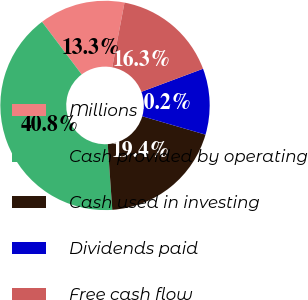<chart> <loc_0><loc_0><loc_500><loc_500><pie_chart><fcel>Millions<fcel>Cash provided by operating<fcel>Cash used in investing<fcel>Dividends paid<fcel>Free cash flow<nl><fcel>13.26%<fcel>40.83%<fcel>19.39%<fcel>10.2%<fcel>16.32%<nl></chart> 